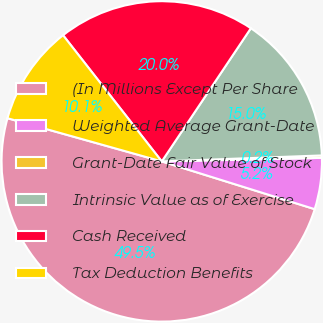<chart> <loc_0><loc_0><loc_500><loc_500><pie_chart><fcel>(In Millions Except Per Share<fcel>Weighted Average Grant-Date<fcel>Grant-Date Fair Value of Stock<fcel>Intrinsic Value as of Exercise<fcel>Cash Received<fcel>Tax Deduction Benefits<nl><fcel>49.53%<fcel>5.17%<fcel>0.24%<fcel>15.02%<fcel>19.95%<fcel>10.09%<nl></chart> 